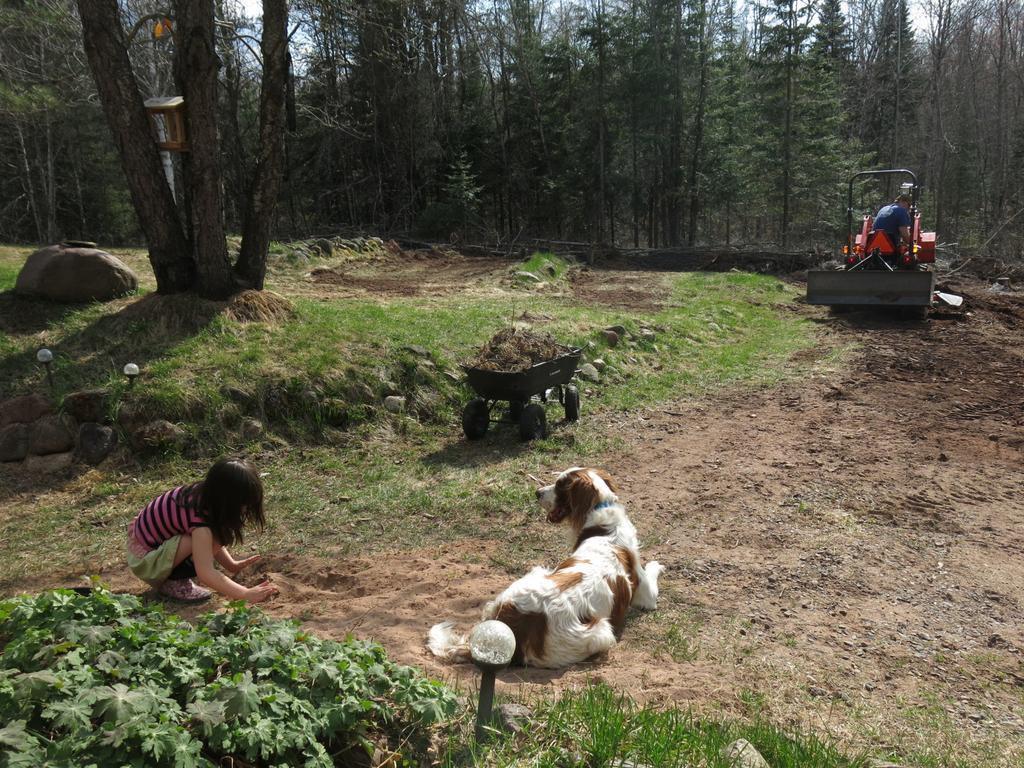In one or two sentences, can you explain what this image depicts? In the image at the bottom there is ground with dog is sleeping and also there is a kid sitting. And there are plants and grass. In the background there are trees and there is a man sitting in the machine. 